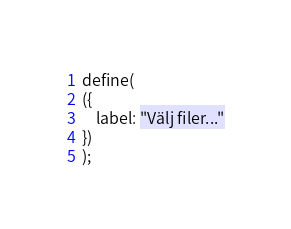Convert code to text. <code><loc_0><loc_0><loc_500><loc_500><_JavaScript_>define(
({
	label: "Välj filer..."
})
);
</code> 